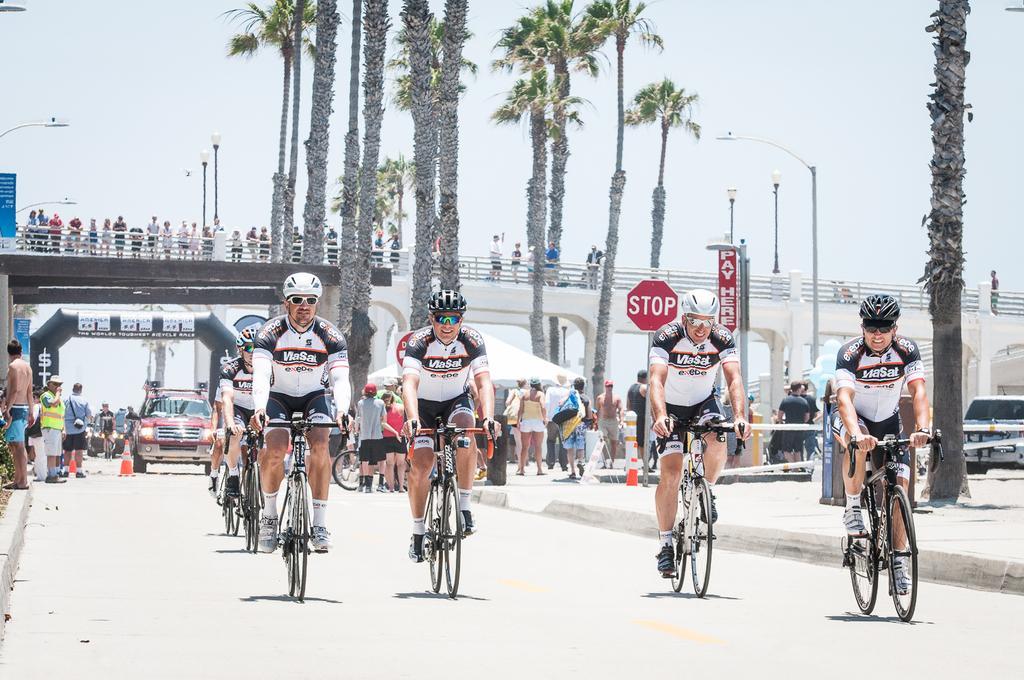How would you summarize this image in a sentence or two? In this image we can see few people riding the bicycles. There are many people in the image. There is the sky in the image. There are few vehicles in the image. There are many street lights in the image. There is a tent in the image. There is a bridge in the image. There are many trees in the image. 